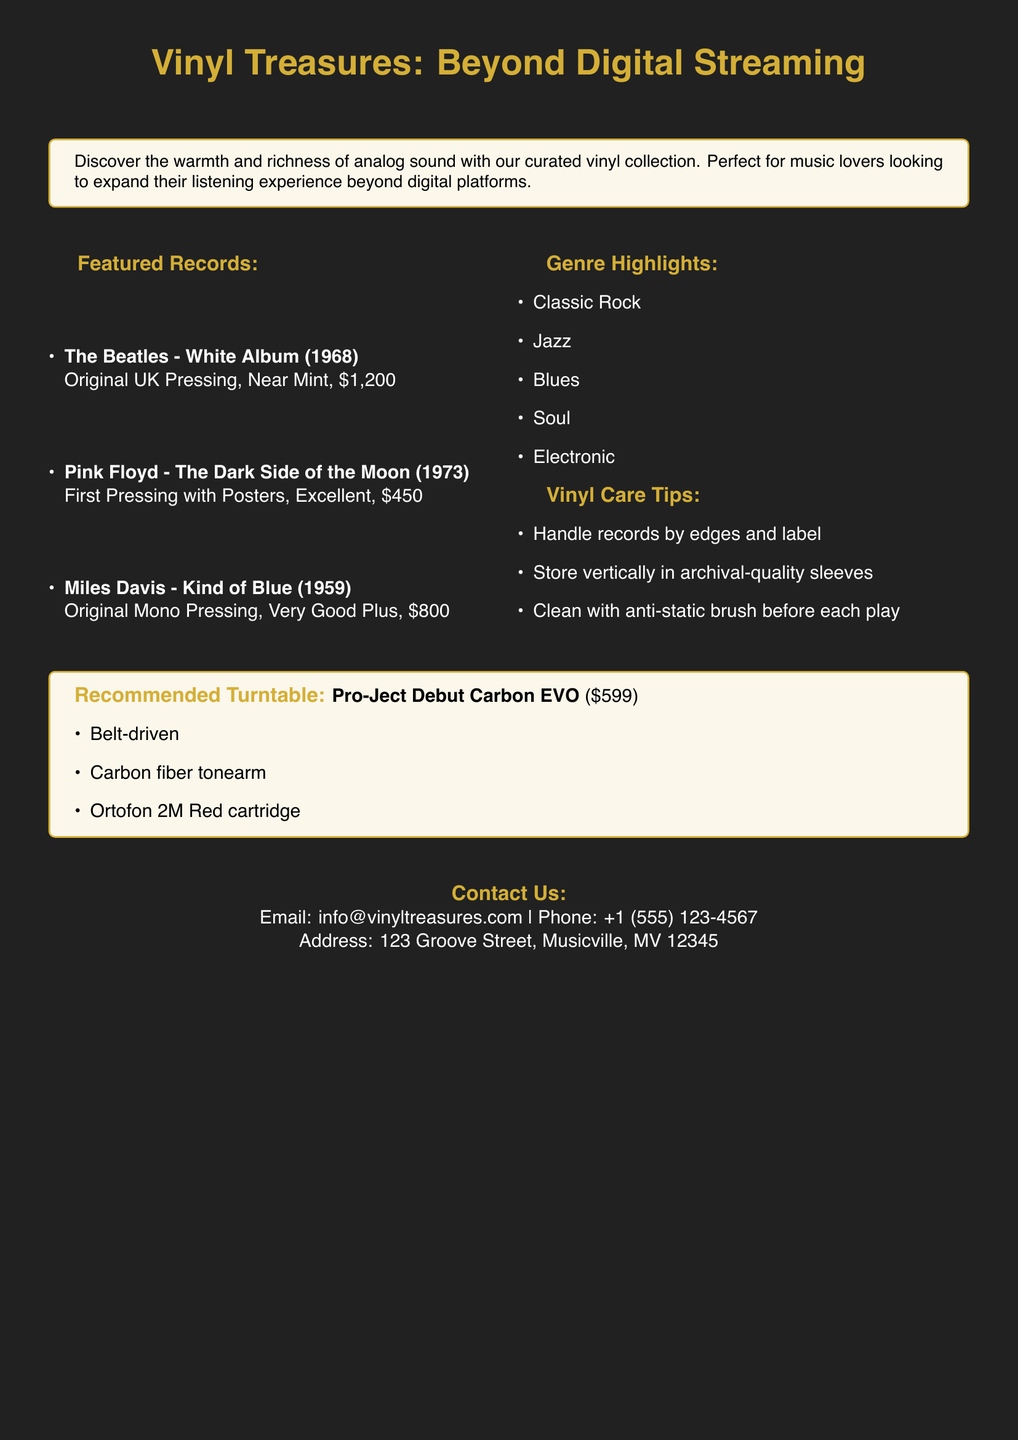What is the price of The Beatles' White Album? The price listed for The Beatles' White Album is \$1,200.
Answer: \$1,200 What year was Pink Floyd's The Dark Side of the Moon released? The document states that Pink Floyd's The Dark Side of the Moon was released in 1973.
Answer: 1973 How many genre highlights are listed in the document? The document includes a list of five genre highlights related to the vinyl collection.
Answer: 5 What type of cartridge does the recommended turntable use? The recommended turntable uses an Ortofon 2M Red cartridge, as mentioned in the document.
Answer: Ortofon 2M Red What is one care tip provided for vinyl records? The document provides several care tips, including handling records by edges and label.
Answer: Handle records by edges and label What condition is Miles Davis's Kind of Blue in? The condition of Miles Davis's Kind of Blue is described as Very Good Plus in the document.
Answer: Very Good Plus What is the recommended turntable model? The document explicitly names the Pro-Ject Debut Carbon EVO as the recommended turntable model.
Answer: Pro-Ject Debut Carbon EVO What color is the page background? The document indicates that the page background color is vinyl black.
Answer: vinyl black 